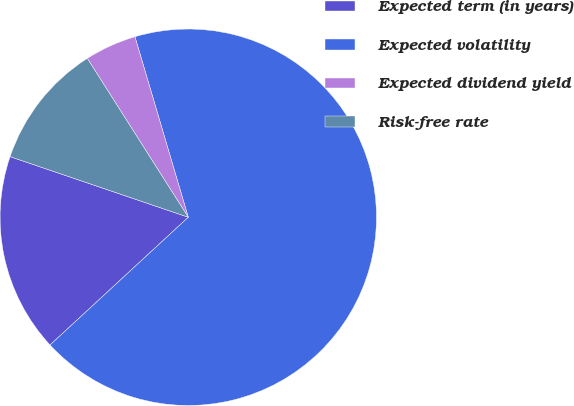Convert chart to OTSL. <chart><loc_0><loc_0><loc_500><loc_500><pie_chart><fcel>Expected term (in years)<fcel>Expected volatility<fcel>Expected dividend yield<fcel>Risk-free rate<nl><fcel>17.09%<fcel>67.69%<fcel>4.44%<fcel>10.77%<nl></chart> 